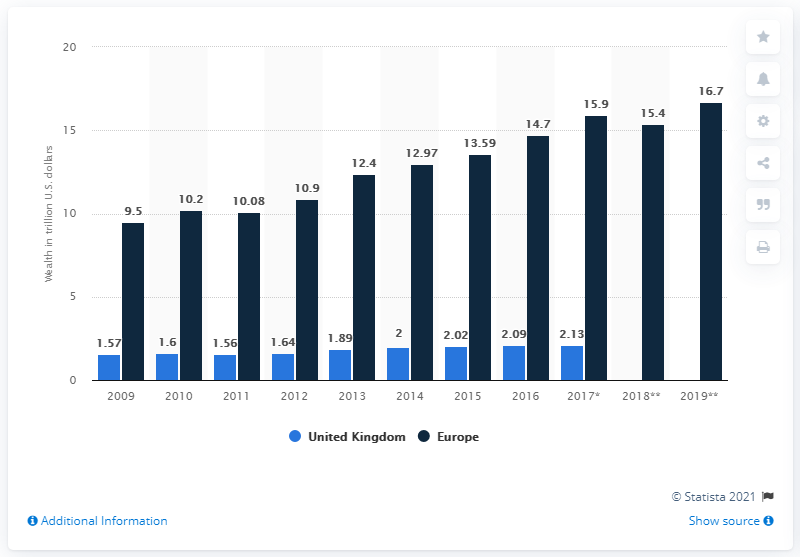Identify some key points in this picture. At the end of 2017, the wealth of high net worth individuals in the UK was approximately 2.09 trillion dollars. The average of the first three bars counted from the left is 4.22... In 2019, high-net-worth individuals in Europe had a total of 16.7 trillion dollars in investable wealth, according to a recent report. The smallest value in the dark blue bar is 9.5. 